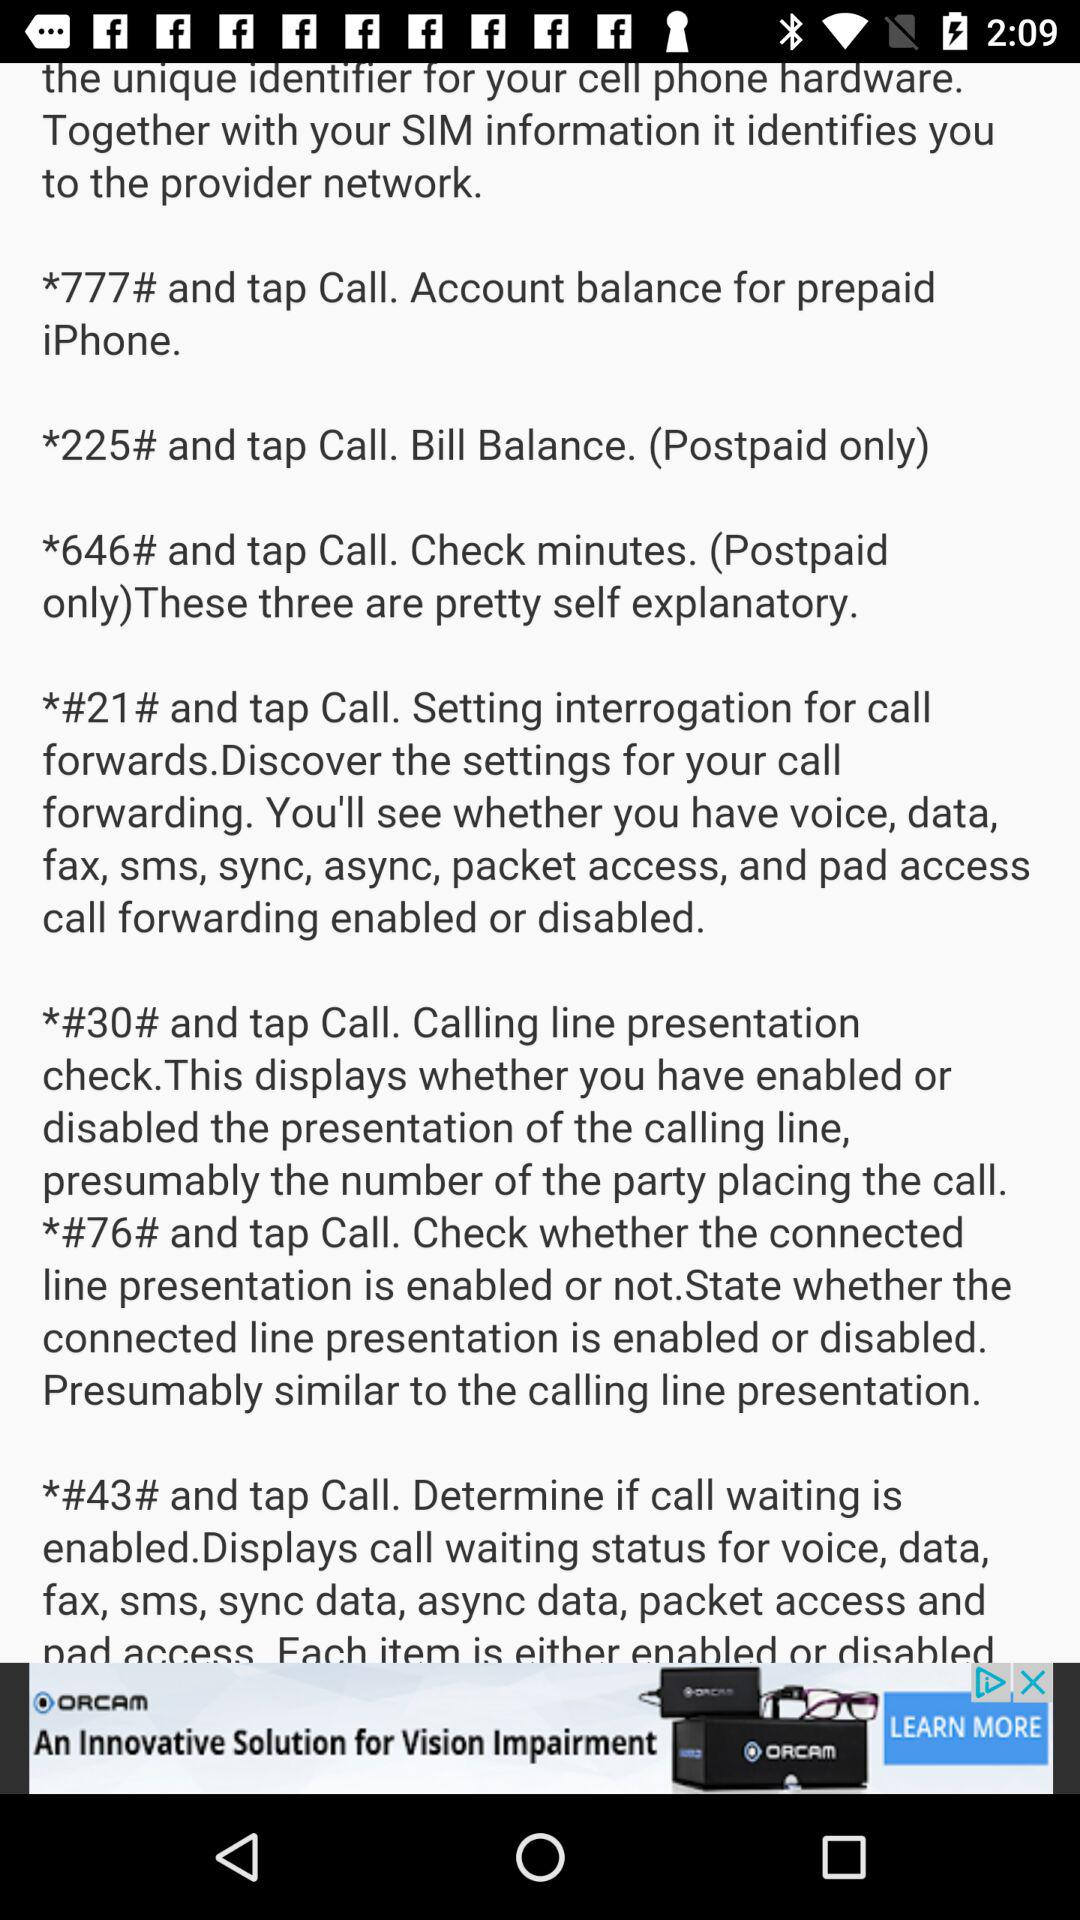What to do to check the bill balance? To check the bill balance, dial *225# and tap call. 